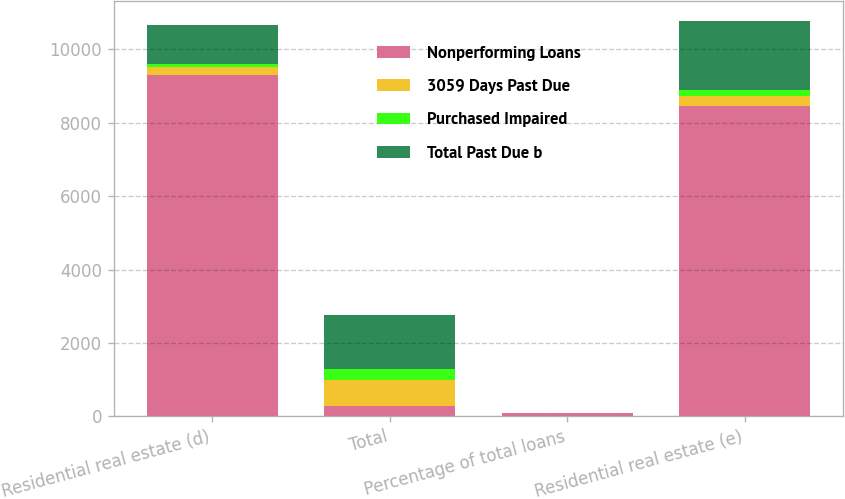Convert chart to OTSL. <chart><loc_0><loc_0><loc_500><loc_500><stacked_bar_chart><ecel><fcel>Residential real estate (d)<fcel>Total<fcel>Percentage of total loans<fcel>Residential real estate (e)<nl><fcel>Nonperforming Loans<fcel>9311<fcel>278<fcel>93.83<fcel>8464<nl><fcel>3059 Days Past Due<fcel>217<fcel>714<fcel>0.37<fcel>278<nl><fcel>Purchased Impaired<fcel>87<fcel>285<fcel>0.15<fcel>146<nl><fcel>Total Past Due b<fcel>1060<fcel>1491<fcel>0.76<fcel>1901<nl></chart> 